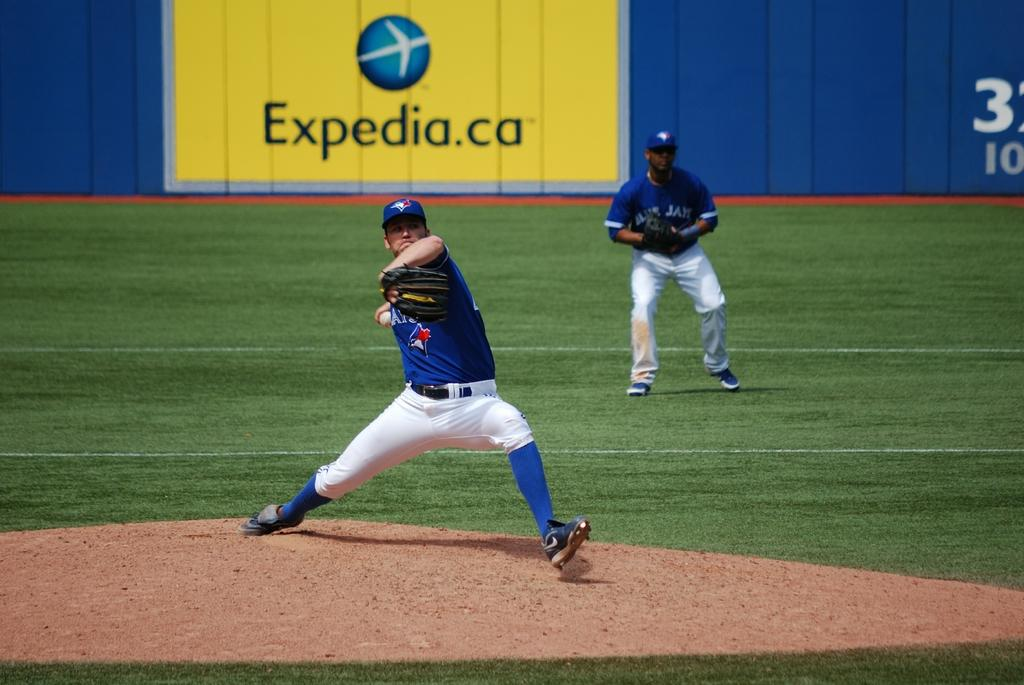<image>
Offer a succinct explanation of the picture presented. A player pitches in front of an outfield advertisement for expedia.ca 